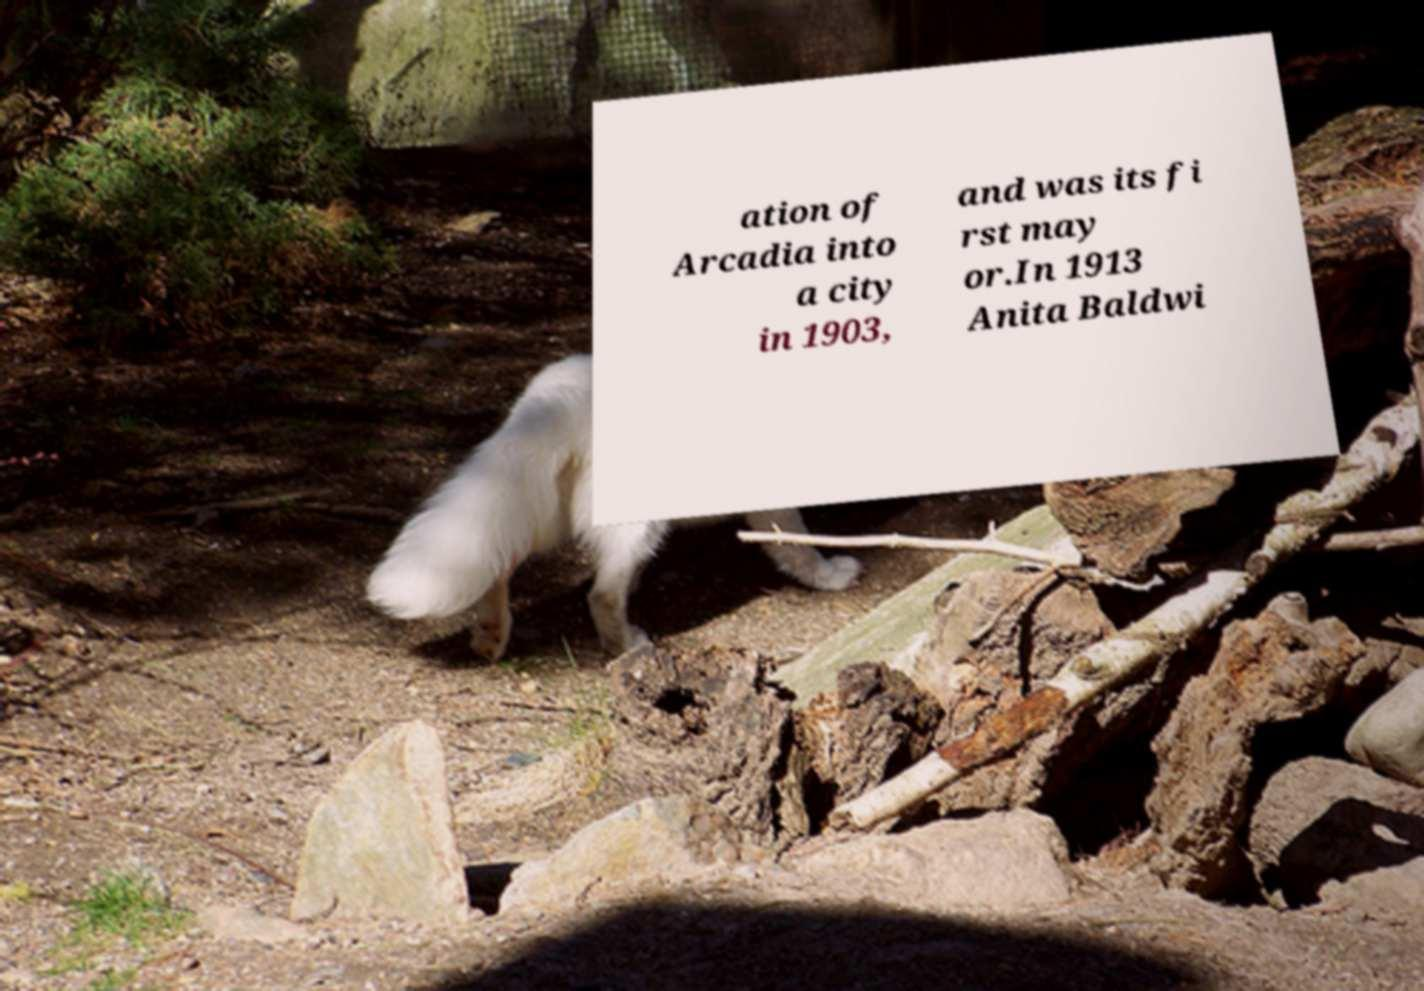Could you extract and type out the text from this image? ation of Arcadia into a city in 1903, and was its fi rst may or.In 1913 Anita Baldwi 